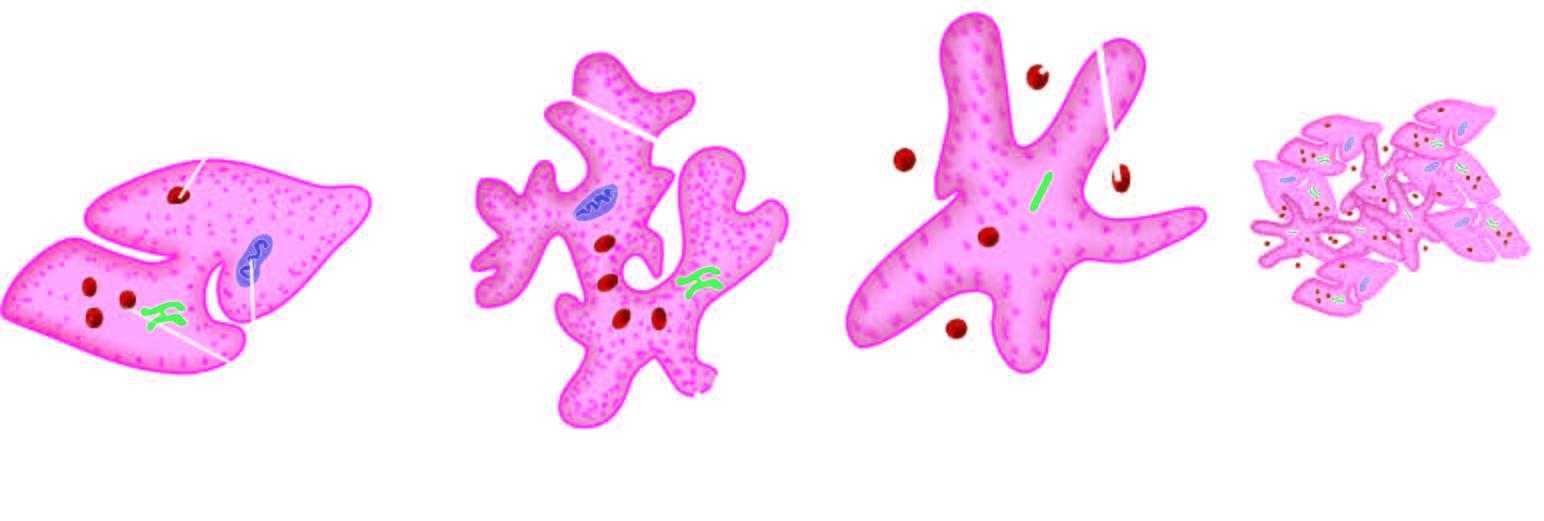what forms a tight plug?
Answer the question using a single word or phrase. Platelet aggregation 